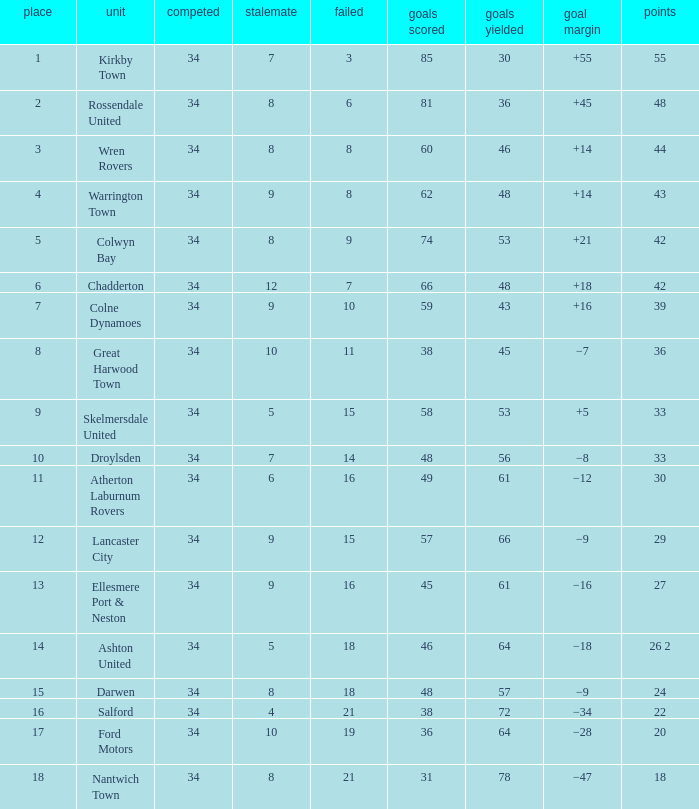What is the total number of positions when there are more than 48 goals against, 1 of 29 points are played, and less than 34 games have been played? 0.0. 